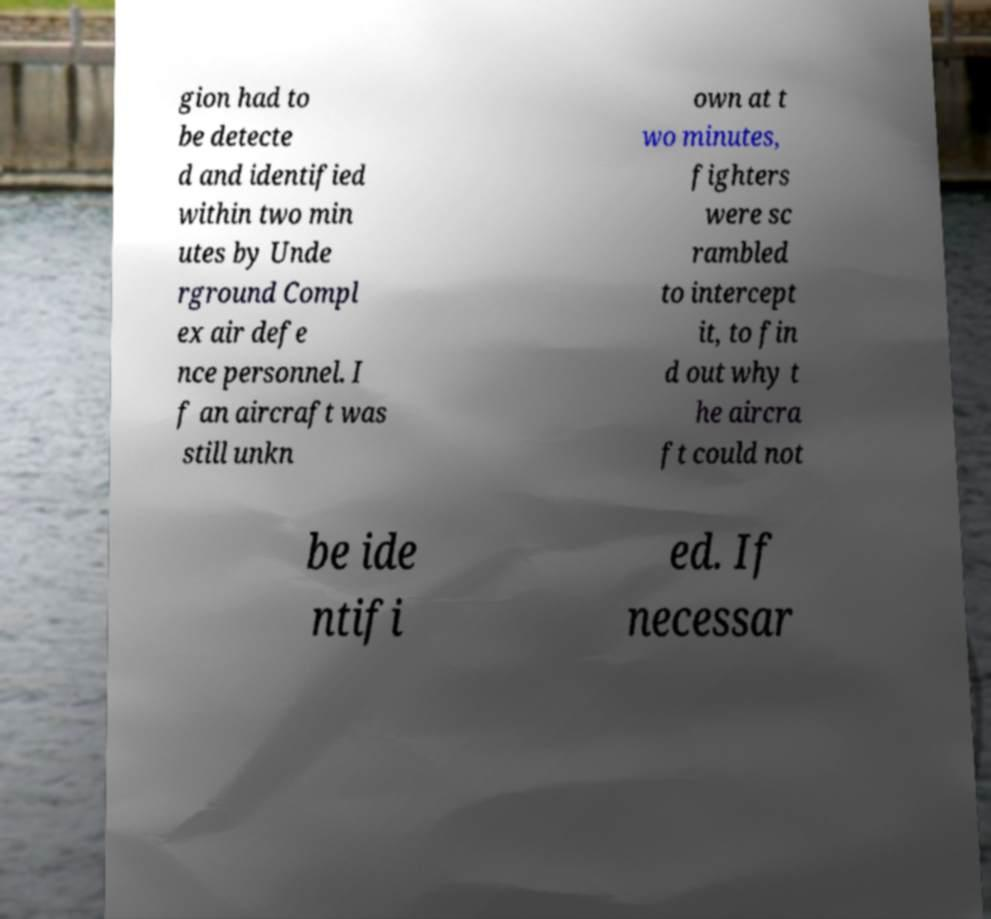Please read and relay the text visible in this image. What does it say? gion had to be detecte d and identified within two min utes by Unde rground Compl ex air defe nce personnel. I f an aircraft was still unkn own at t wo minutes, fighters were sc rambled to intercept it, to fin d out why t he aircra ft could not be ide ntifi ed. If necessar 